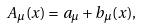<formula> <loc_0><loc_0><loc_500><loc_500>A _ { \mu } ( x ) = a _ { \mu } + b _ { \mu } ( x ) ,</formula> 